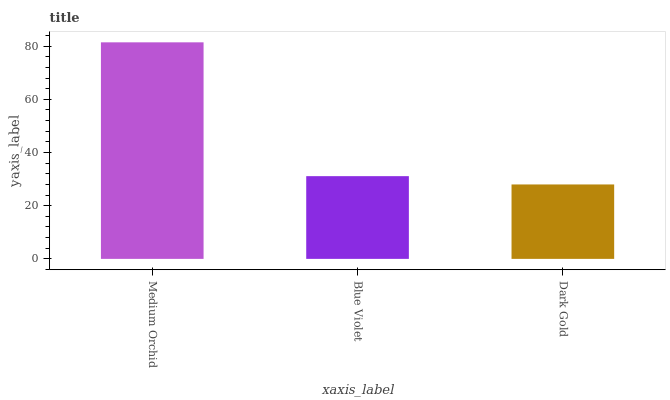Is Blue Violet the minimum?
Answer yes or no. No. Is Blue Violet the maximum?
Answer yes or no. No. Is Medium Orchid greater than Blue Violet?
Answer yes or no. Yes. Is Blue Violet less than Medium Orchid?
Answer yes or no. Yes. Is Blue Violet greater than Medium Orchid?
Answer yes or no. No. Is Medium Orchid less than Blue Violet?
Answer yes or no. No. Is Blue Violet the high median?
Answer yes or no. Yes. Is Blue Violet the low median?
Answer yes or no. Yes. Is Medium Orchid the high median?
Answer yes or no. No. Is Dark Gold the low median?
Answer yes or no. No. 